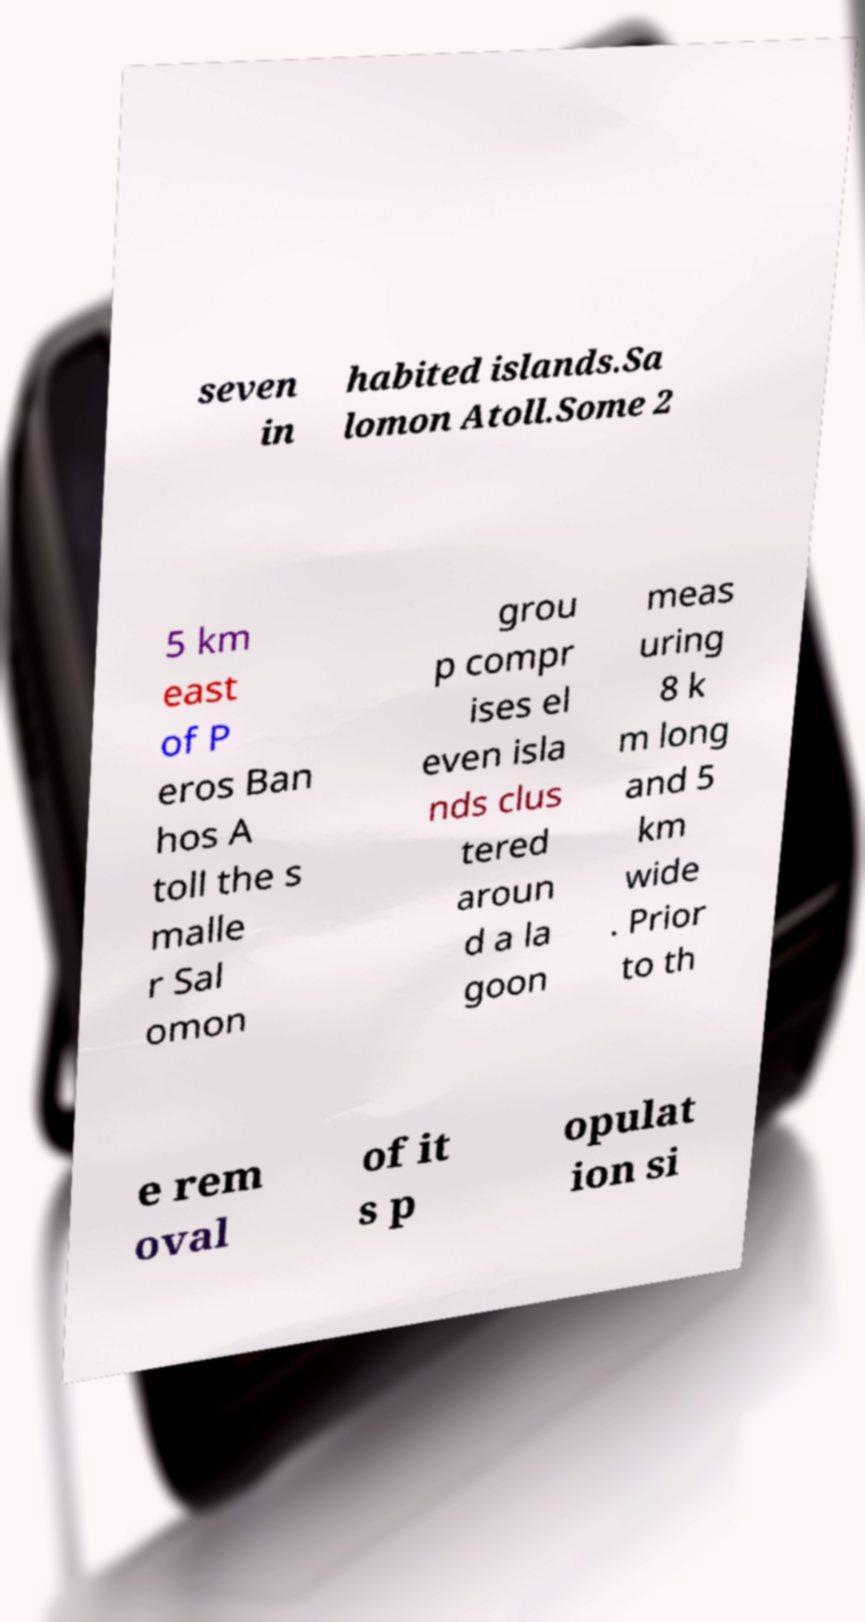There's text embedded in this image that I need extracted. Can you transcribe it verbatim? seven in habited islands.Sa lomon Atoll.Some 2 5 km east of P eros Ban hos A toll the s malle r Sal omon grou p compr ises el even isla nds clus tered aroun d a la goon meas uring 8 k m long and 5 km wide . Prior to th e rem oval of it s p opulat ion si 